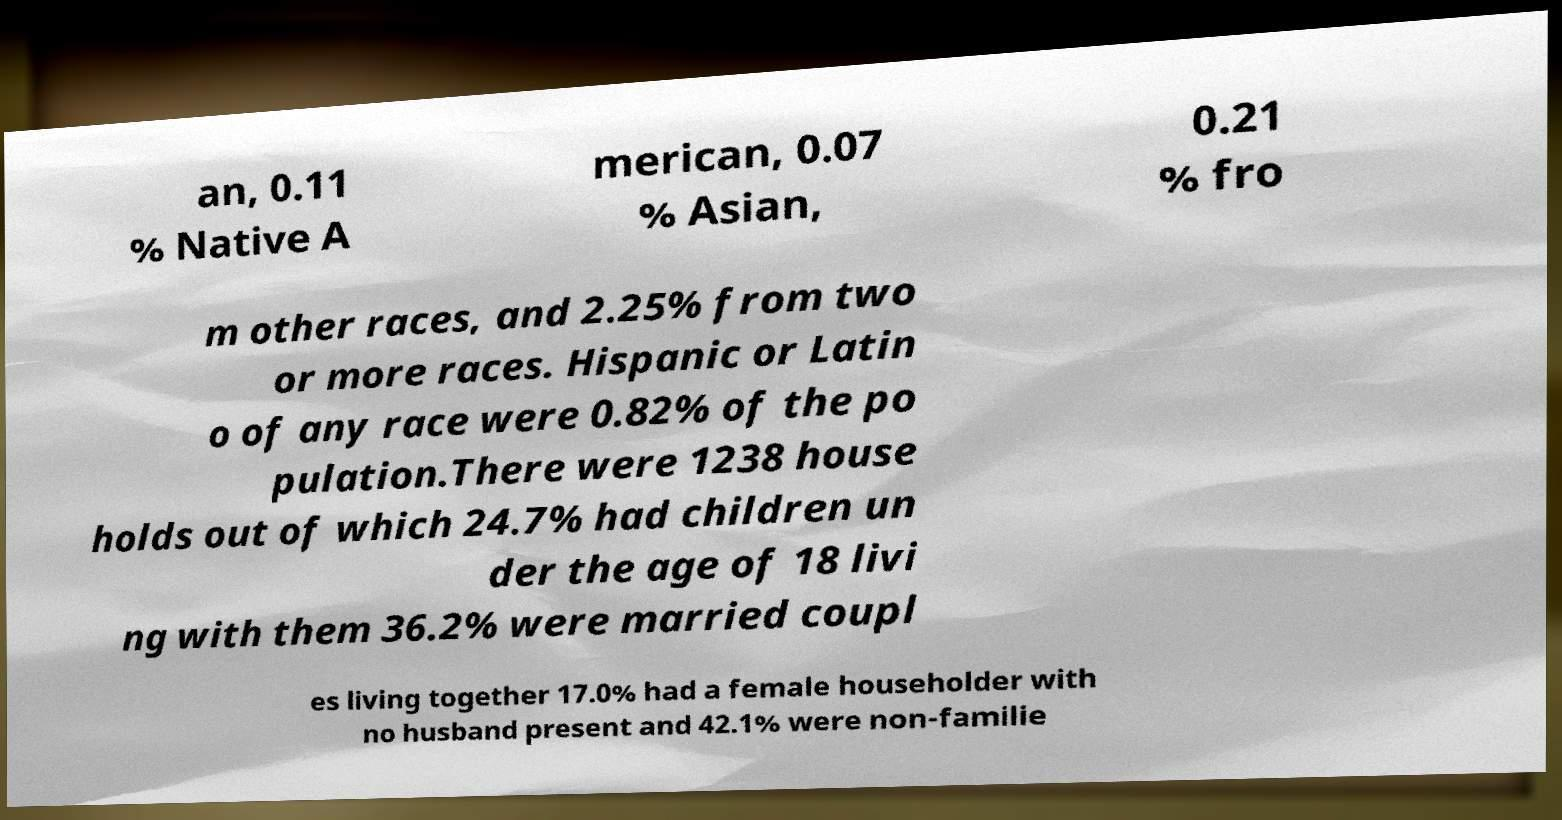For documentation purposes, I need the text within this image transcribed. Could you provide that? an, 0.11 % Native A merican, 0.07 % Asian, 0.21 % fro m other races, and 2.25% from two or more races. Hispanic or Latin o of any race were 0.82% of the po pulation.There were 1238 house holds out of which 24.7% had children un der the age of 18 livi ng with them 36.2% were married coupl es living together 17.0% had a female householder with no husband present and 42.1% were non-familie 